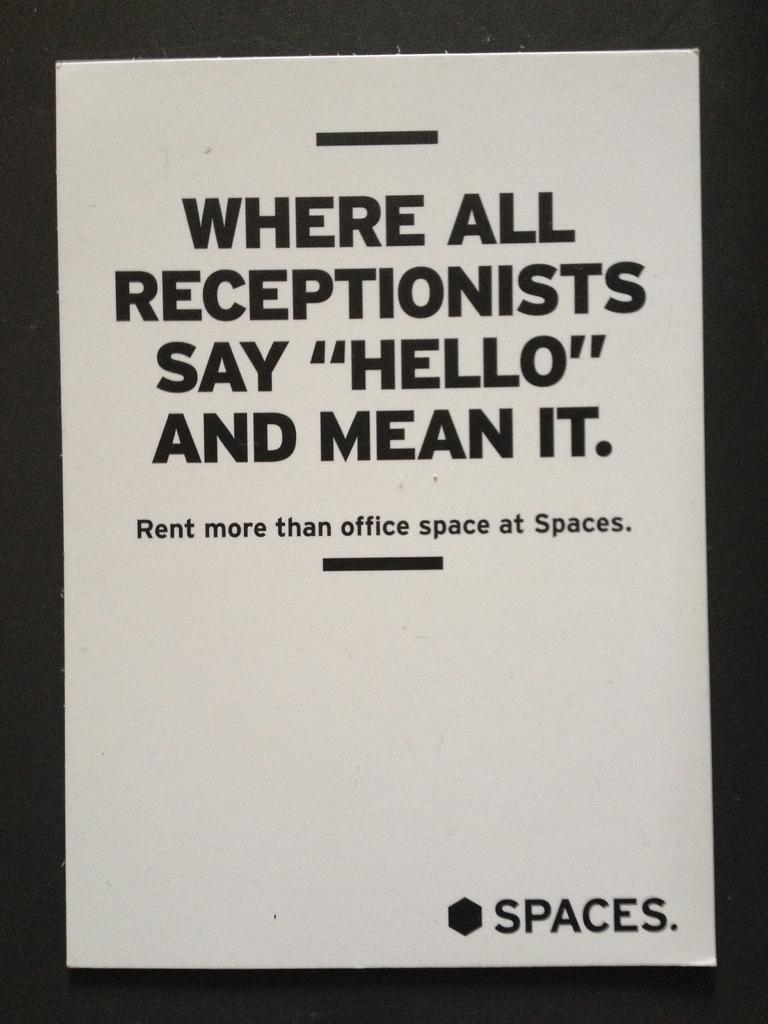<image>
Provide a brief description of the given image. An advertisement for an office rental company called Spaces. 